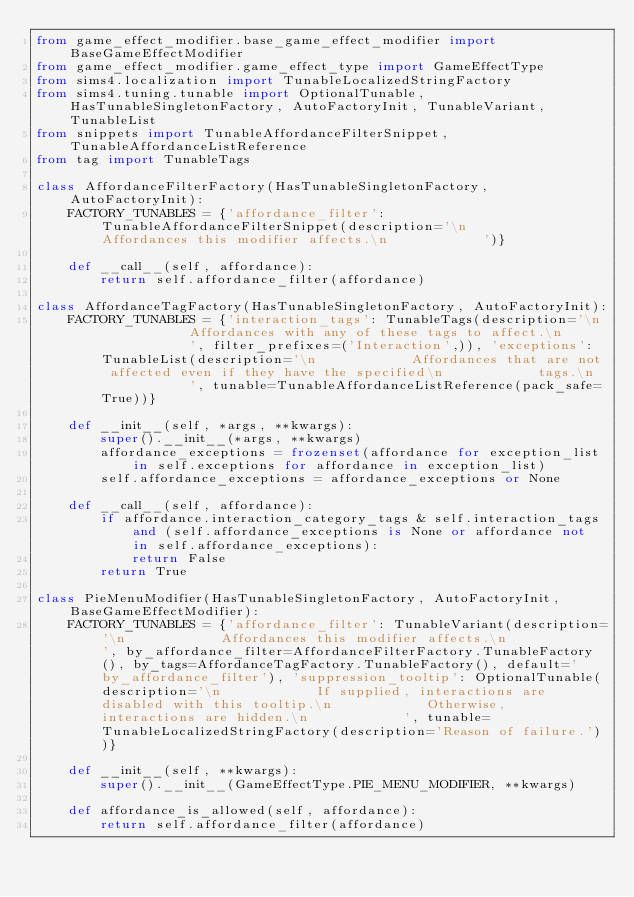Convert code to text. <code><loc_0><loc_0><loc_500><loc_500><_Python_>from game_effect_modifier.base_game_effect_modifier import BaseGameEffectModifier
from game_effect_modifier.game_effect_type import GameEffectType
from sims4.localization import TunableLocalizedStringFactory
from sims4.tuning.tunable import OptionalTunable, HasTunableSingletonFactory, AutoFactoryInit, TunableVariant, TunableList
from snippets import TunableAffordanceFilterSnippet, TunableAffordanceListReference
from tag import TunableTags

class AffordanceFilterFactory(HasTunableSingletonFactory, AutoFactoryInit):
    FACTORY_TUNABLES = {'affordance_filter': TunableAffordanceFilterSnippet(description='\n            Affordances this modifier affects.\n            ')}

    def __call__(self, affordance):
        return self.affordance_filter(affordance)

class AffordanceTagFactory(HasTunableSingletonFactory, AutoFactoryInit):
    FACTORY_TUNABLES = {'interaction_tags': TunableTags(description='\n            Affordances with any of these tags to affect.\n            ', filter_prefixes=('Interaction',)), 'exceptions': TunableList(description='\n            Affordances that are not affected even if they have the specified\n            tags.\n            ', tunable=TunableAffordanceListReference(pack_safe=True))}

    def __init__(self, *args, **kwargs):
        super().__init__(*args, **kwargs)
        affordance_exceptions = frozenset(affordance for exception_list in self.exceptions for affordance in exception_list)
        self.affordance_exceptions = affordance_exceptions or None

    def __call__(self, affordance):
        if affordance.interaction_category_tags & self.interaction_tags and (self.affordance_exceptions is None or affordance not in self.affordance_exceptions):
            return False
        return True

class PieMenuModifier(HasTunableSingletonFactory, AutoFactoryInit, BaseGameEffectModifier):
    FACTORY_TUNABLES = {'affordance_filter': TunableVariant(description='\n            Affordances this modifier affects.\n            ', by_affordance_filter=AffordanceFilterFactory.TunableFactory(), by_tags=AffordanceTagFactory.TunableFactory(), default='by_affordance_filter'), 'suppression_tooltip': OptionalTunable(description='\n            If supplied, interactions are disabled with this tooltip.\n            Otherwise, interactions are hidden.\n            ', tunable=TunableLocalizedStringFactory(description='Reason of failure.'))}

    def __init__(self, **kwargs):
        super().__init__(GameEffectType.PIE_MENU_MODIFIER, **kwargs)

    def affordance_is_allowed(self, affordance):
        return self.affordance_filter(affordance)
</code> 